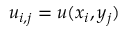Convert formula to latex. <formula><loc_0><loc_0><loc_500><loc_500>u _ { i , j } = u ( x _ { i } , y _ { j } )</formula> 